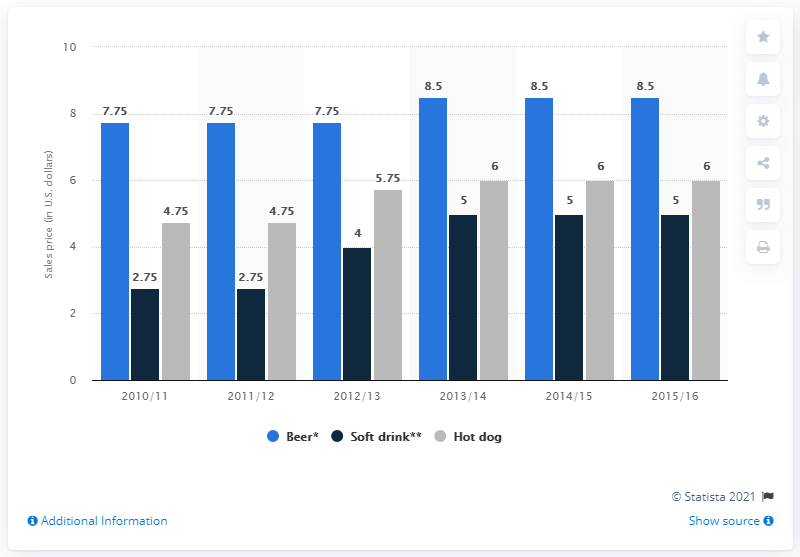Specify some key components in this picture. The highest concession stand prices for Brooklyn Nets games from the 2010/11 to 2015/16 seasons ranged from 8.5 U.S. dollars. In the 2012/13 season, the cost of a 16 ounce beer was approximately 7.75. The difference between the highest and the lowest dark blue bar is 2.25. 